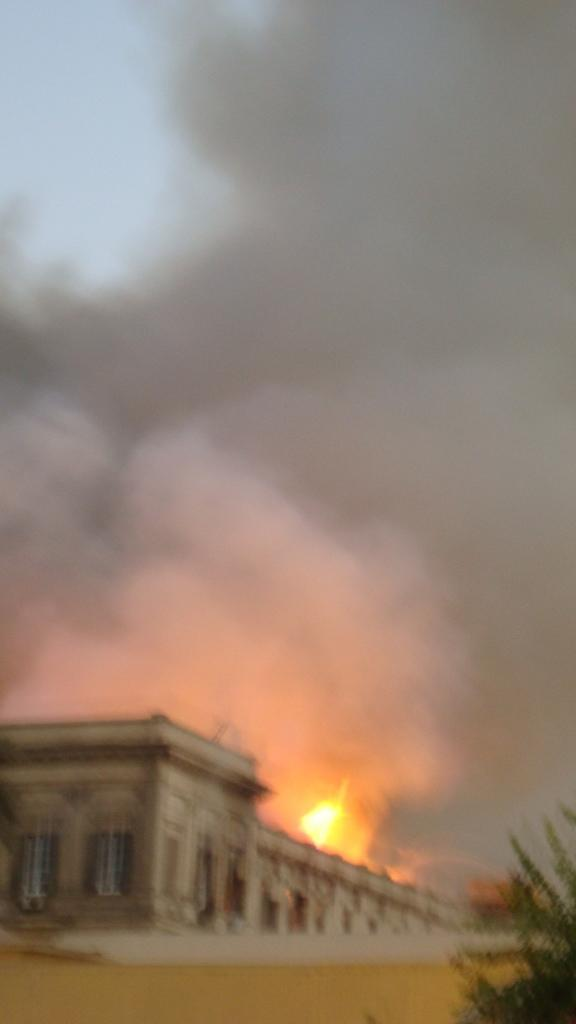What type of structure is in the image? There is a big building in the image. What natural element is present in the image? There is a tree in the image. What type of terrain is visible in the image? There is sand visible in the image. What is the source of the smoke in the image? There is fire with smoke in the image. What part of the natural environment is visible in the image? The sky is visible at the top of the image. How many flowers are present in the image? There are no flowers visible in the image. What type of account is being discussed in the image? There is no account being discussed in the image. 